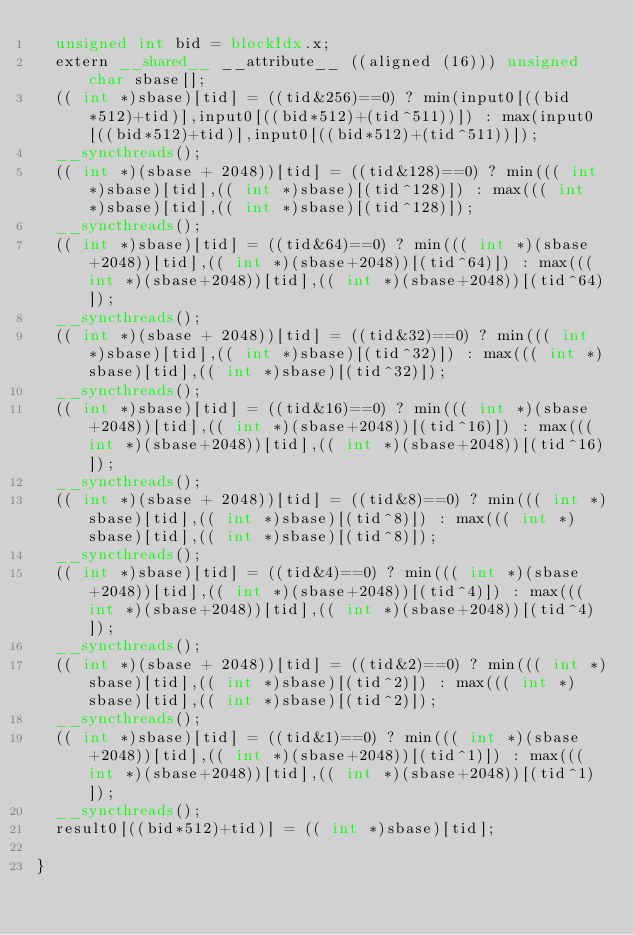Convert code to text. <code><loc_0><loc_0><loc_500><loc_500><_Cuda_>  unsigned int bid = blockIdx.x;
  extern __shared__ __attribute__ ((aligned (16))) unsigned char sbase[];
  (( int *)sbase)[tid] = ((tid&256)==0) ? min(input0[((bid*512)+tid)],input0[((bid*512)+(tid^511))]) : max(input0[((bid*512)+tid)],input0[((bid*512)+(tid^511))]);
  __syncthreads();
  (( int *)(sbase + 2048))[tid] = ((tid&128)==0) ? min((( int *)sbase)[tid],(( int *)sbase)[(tid^128)]) : max((( int *)sbase)[tid],(( int *)sbase)[(tid^128)]);
  __syncthreads();
  (( int *)sbase)[tid] = ((tid&64)==0) ? min((( int *)(sbase+2048))[tid],(( int *)(sbase+2048))[(tid^64)]) : max((( int *)(sbase+2048))[tid],(( int *)(sbase+2048))[(tid^64)]);
  __syncthreads();
  (( int *)(sbase + 2048))[tid] = ((tid&32)==0) ? min((( int *)sbase)[tid],(( int *)sbase)[(tid^32)]) : max((( int *)sbase)[tid],(( int *)sbase)[(tid^32)]);
  __syncthreads();
  (( int *)sbase)[tid] = ((tid&16)==0) ? min((( int *)(sbase+2048))[tid],(( int *)(sbase+2048))[(tid^16)]) : max((( int *)(sbase+2048))[tid],(( int *)(sbase+2048))[(tid^16)]);
  __syncthreads();
  (( int *)(sbase + 2048))[tid] = ((tid&8)==0) ? min((( int *)sbase)[tid],(( int *)sbase)[(tid^8)]) : max((( int *)sbase)[tid],(( int *)sbase)[(tid^8)]);
  __syncthreads();
  (( int *)sbase)[tid] = ((tid&4)==0) ? min((( int *)(sbase+2048))[tid],(( int *)(sbase+2048))[(tid^4)]) : max((( int *)(sbase+2048))[tid],(( int *)(sbase+2048))[(tid^4)]);
  __syncthreads();
  (( int *)(sbase + 2048))[tid] = ((tid&2)==0) ? min((( int *)sbase)[tid],(( int *)sbase)[(tid^2)]) : max((( int *)sbase)[tid],(( int *)sbase)[(tid^2)]);
  __syncthreads();
  (( int *)sbase)[tid] = ((tid&1)==0) ? min((( int *)(sbase+2048))[tid],(( int *)(sbase+2048))[(tid^1)]) : max((( int *)(sbase+2048))[tid],(( int *)(sbase+2048))[(tid^1)]);
  __syncthreads();
  result0[((bid*512)+tid)] = (( int *)sbase)[tid];
  
}
</code> 